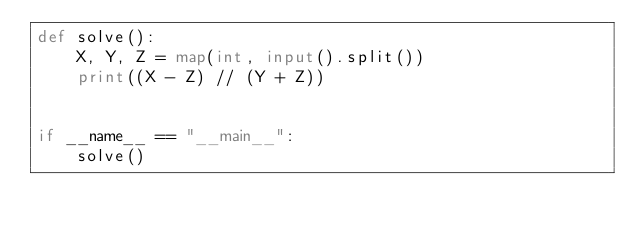Convert code to text. <code><loc_0><loc_0><loc_500><loc_500><_Python_>def solve():
    X, Y, Z = map(int, input().split())
    print((X - Z) // (Y + Z))


if __name__ == "__main__":
    solve()</code> 